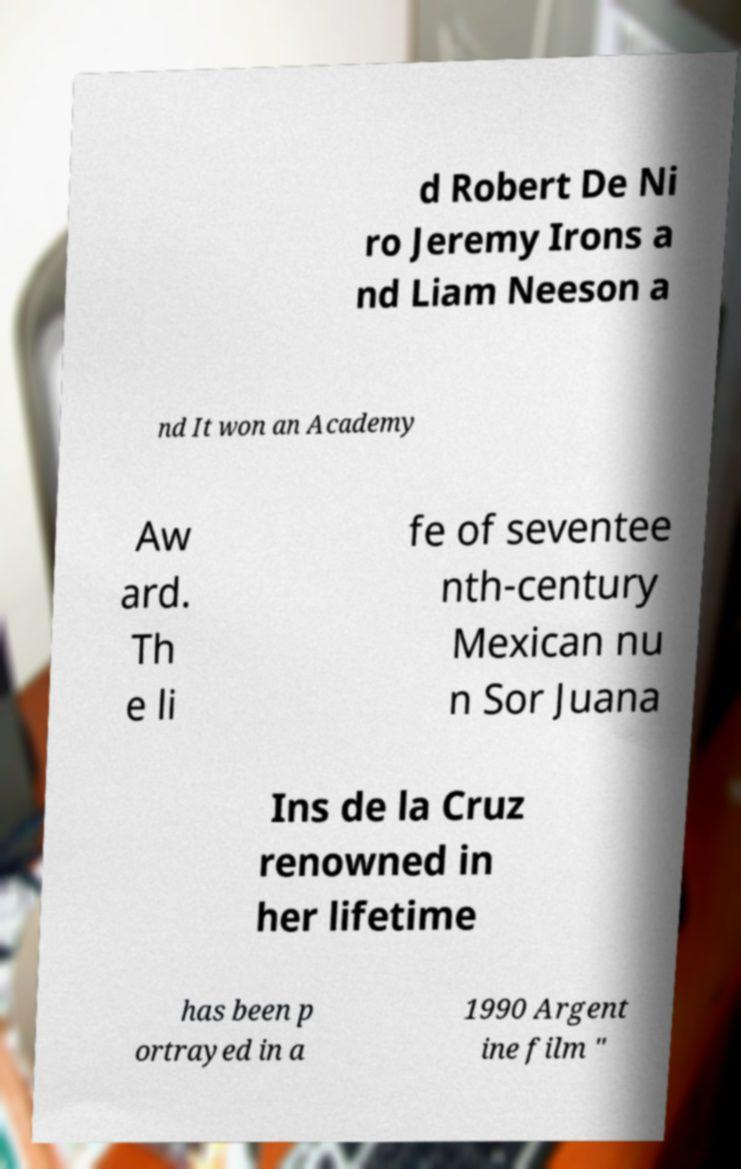Please identify and transcribe the text found in this image. d Robert De Ni ro Jeremy Irons a nd Liam Neeson a nd It won an Academy Aw ard. Th e li fe of seventee nth-century Mexican nu n Sor Juana Ins de la Cruz renowned in her lifetime has been p ortrayed in a 1990 Argent ine film " 